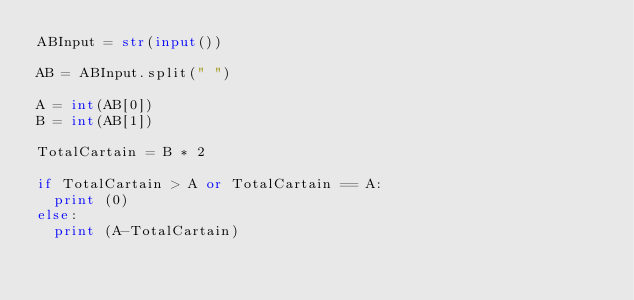Convert code to text. <code><loc_0><loc_0><loc_500><loc_500><_Python_>ABInput = str(input())
 
AB = ABInput.split(" ")
 
A = int(AB[0])
B = int(AB[1])
 
TotalCartain = B * 2
 
if TotalCartain > A or TotalCartain == A:
  print (0)
else:
  print (A-TotalCartain)</code> 